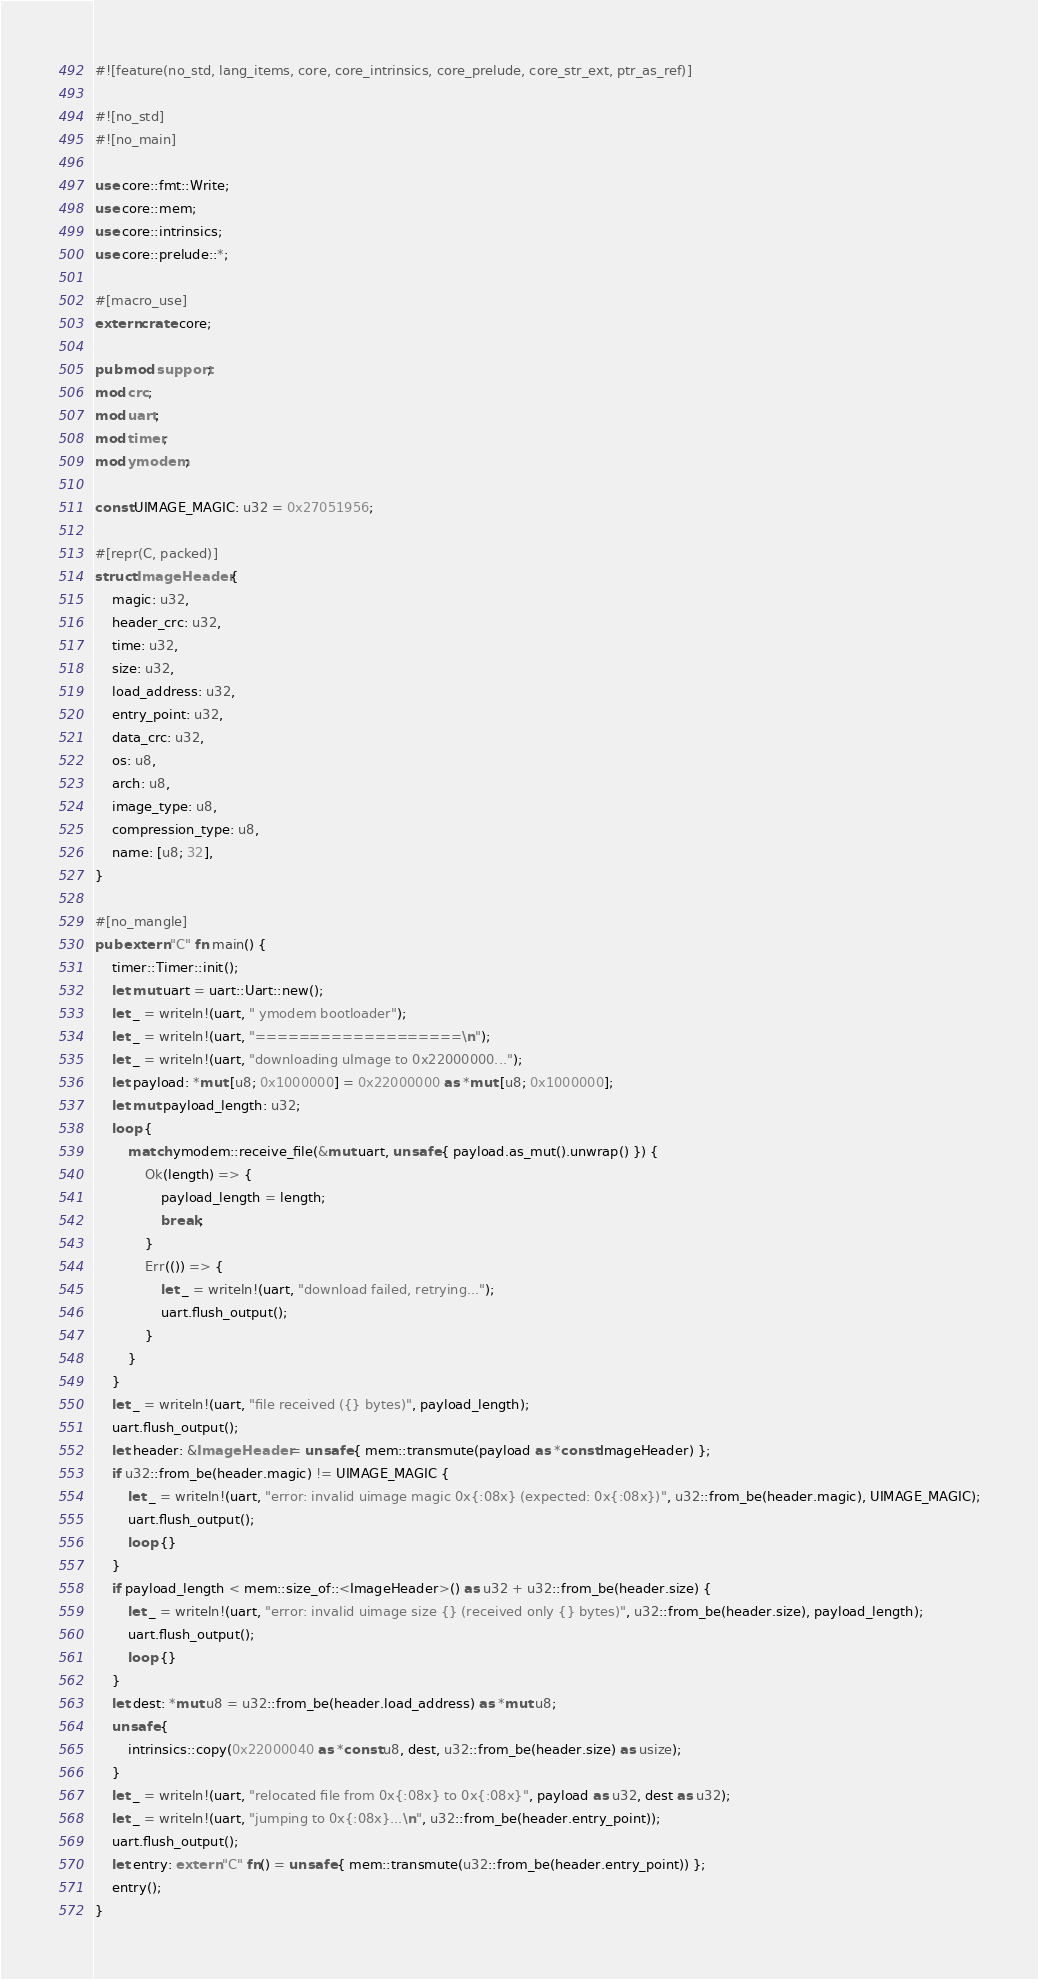Convert code to text. <code><loc_0><loc_0><loc_500><loc_500><_Rust_>#![feature(no_std, lang_items, core, core_intrinsics, core_prelude, core_str_ext, ptr_as_ref)]

#![no_std]
#![no_main]

use core::fmt::Write;
use core::mem;
use core::intrinsics;
use core::prelude::*;

#[macro_use]
extern crate core;

pub mod support;
mod crc;
mod uart;
mod timer;
mod ymodem;

const UIMAGE_MAGIC: u32 = 0x27051956;

#[repr(C, packed)]
struct ImageHeader {
    magic: u32,
    header_crc: u32,
    time: u32,
    size: u32,
    load_address: u32,
    entry_point: u32,
    data_crc: u32,
    os: u8,
    arch: u8,
    image_type: u8,
    compression_type: u8,
    name: [u8; 32],
}

#[no_mangle]
pub extern "C" fn main() {
    timer::Timer::init();
    let mut uart = uart::Uart::new();
    let _ = writeln!(uart, " ymodem bootloader");
    let _ = writeln!(uart, "===================\n");
    let _ = writeln!(uart, "downloading uImage to 0x22000000...");
    let payload: *mut [u8; 0x1000000] = 0x22000000 as *mut [u8; 0x1000000];
    let mut payload_length: u32;
    loop {
        match ymodem::receive_file(&mut uart, unsafe { payload.as_mut().unwrap() }) {
            Ok(length) => {
                payload_length = length;
                break;
            }
            Err(()) => {
                let _ = writeln!(uart, "download failed, retrying...");
                uart.flush_output();
            }
        }
    }
    let _ = writeln!(uart, "file received ({} bytes)", payload_length);
    uart.flush_output();
    let header: &ImageHeader = unsafe { mem::transmute(payload as *const ImageHeader) };
    if u32::from_be(header.magic) != UIMAGE_MAGIC {
        let _ = writeln!(uart, "error: invalid uimage magic 0x{:08x} (expected: 0x{:08x})", u32::from_be(header.magic), UIMAGE_MAGIC);
        uart.flush_output();
        loop {}
    }
    if payload_length < mem::size_of::<ImageHeader>() as u32 + u32::from_be(header.size) {
        let _ = writeln!(uart, "error: invalid uimage size {} (received only {} bytes)", u32::from_be(header.size), payload_length);
        uart.flush_output();
        loop {}
    }
    let dest: *mut u8 = u32::from_be(header.load_address) as *mut u8;
    unsafe {
        intrinsics::copy(0x22000040 as *const u8, dest, u32::from_be(header.size) as usize);
    }
    let _ = writeln!(uart, "relocated file from 0x{:08x} to 0x{:08x}", payload as u32, dest as u32);
    let _ = writeln!(uart, "jumping to 0x{:08x}...\n", u32::from_be(header.entry_point));
    uart.flush_output();
    let entry: extern "C" fn() = unsafe { mem::transmute(u32::from_be(header.entry_point)) };
    entry();
}

</code> 